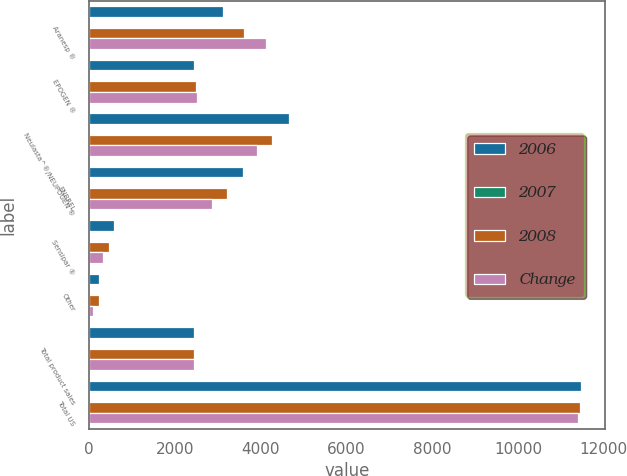Convert chart. <chart><loc_0><loc_0><loc_500><loc_500><stacked_bar_chart><ecel><fcel>Aranesp ®<fcel>EPOGEN ®<fcel>Neulasta^®/NEUPOGEN ®<fcel>ENBREL<fcel>Sensipar ®<fcel>Other<fcel>Total product sales<fcel>Total US<nl><fcel>2006<fcel>3137<fcel>2456<fcel>4659<fcel>3598<fcel>597<fcel>240<fcel>2456<fcel>11460<nl><fcel>2007<fcel>13<fcel>1<fcel>9<fcel>11<fcel>29<fcel>1<fcel>3<fcel>0<nl><fcel>2008<fcel>3614<fcel>2489<fcel>4277<fcel>3230<fcel>463<fcel>238<fcel>2456<fcel>11443<nl><fcel>Change<fcel>4121<fcel>2511<fcel>3923<fcel>2879<fcel>321<fcel>103<fcel>2456<fcel>11397<nl></chart> 